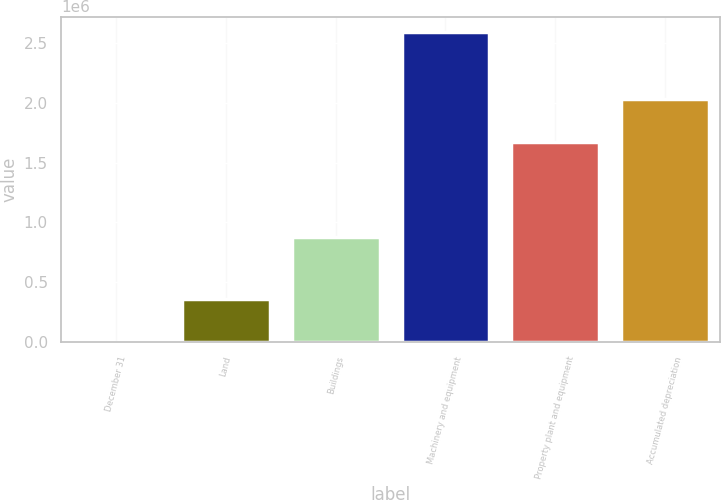<chart> <loc_0><loc_0><loc_500><loc_500><bar_chart><fcel>December 31<fcel>Land<fcel>Buildings<fcel>Machinery and equipment<fcel>Property plant and equipment<fcel>Accumulated depreciation<nl><fcel>2012<fcel>357873<fcel>878527<fcel>2.58918e+06<fcel>1.67407e+06<fcel>2.02993e+06<nl></chart> 